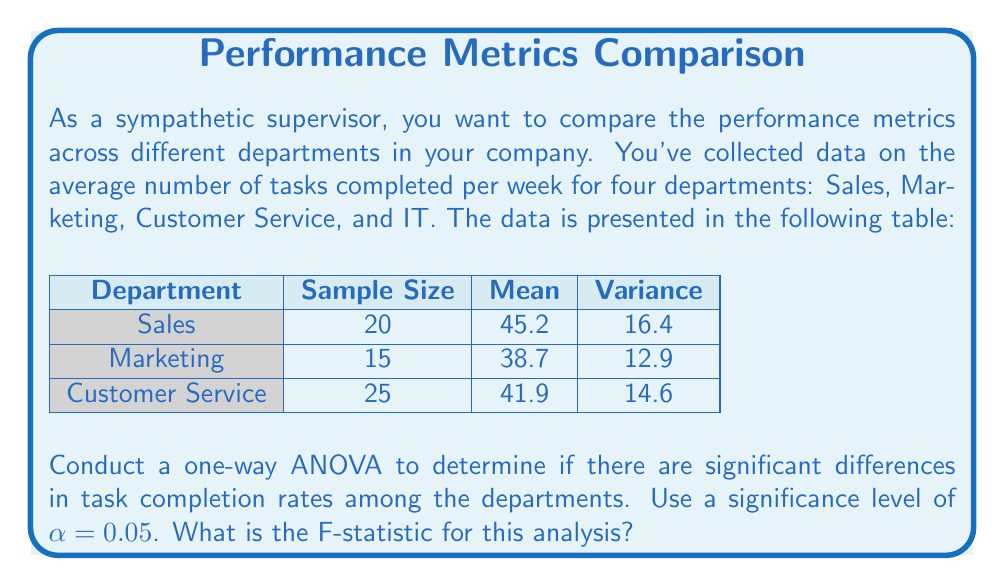Give your solution to this math problem. To conduct a one-way ANOVA, we'll follow these steps:

1) Calculate the total sum of squares (SST):
   $$SST = \sum_{i=1}^k \sum_{j=1}^{n_i} (X_{ij} - \bar{X})^2$$
   where $k$ is the number of groups, $n_i$ is the sample size of each group, and $\bar{X}$ is the grand mean.

2) Calculate the between-group sum of squares (SSB):
   $$SSB = \sum_{i=1}^k n_i(\bar{X_i} - \bar{X})^2$$
   where $\bar{X_i}$ is the mean of each group.

3) Calculate the within-group sum of squares (SSW):
   $$SSW = SST - SSB$$

4) Calculate the degrees of freedom:
   - Between groups: $df_B = k - 1 = 3$
   - Within groups: $df_W = N - k = 60 - 3 = 57$
   where $N$ is the total sample size.

5) Calculate the mean squares:
   $$MSB = \frac{SSB}{df_B}$$
   $$MSW = \frac{SSW}{df_W}$$

6) Calculate the F-statistic:
   $$F = \frac{MSB}{MSW}$$

Let's calculate:

Grand mean: $\bar{X} = \frac{20(45.2) + 15(38.7) + 25(41.9)}{60} = 42.15$

SSB = $20(45.2 - 42.15)^2 + 15(38.7 - 42.15)^2 + 25(41.9 - 42.15)^2 = 409.725$

SSW = $19(16.4) + 14(12.9) + 24(14.6) = 842.6$

SST = SSB + SSW = 409.725 + 842.6 = 1252.325

MSB = $\frac{409.725}{3} = 136.575$

MSW = $\frac{842.6}{57} = 14.782$

F-statistic = $\frac{136.575}{14.782} = 9.239$
Answer: 9.239 